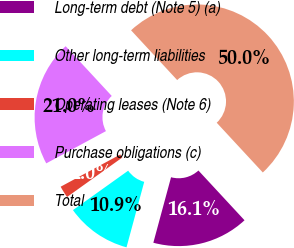Convert chart to OTSL. <chart><loc_0><loc_0><loc_500><loc_500><pie_chart><fcel>Long-term debt (Note 5) (a)<fcel>Other long-term liabilities<fcel>Operating leases (Note 6)<fcel>Purchase obligations (c)<fcel>Total<nl><fcel>16.1%<fcel>10.92%<fcel>1.99%<fcel>20.99%<fcel>50.0%<nl></chart> 